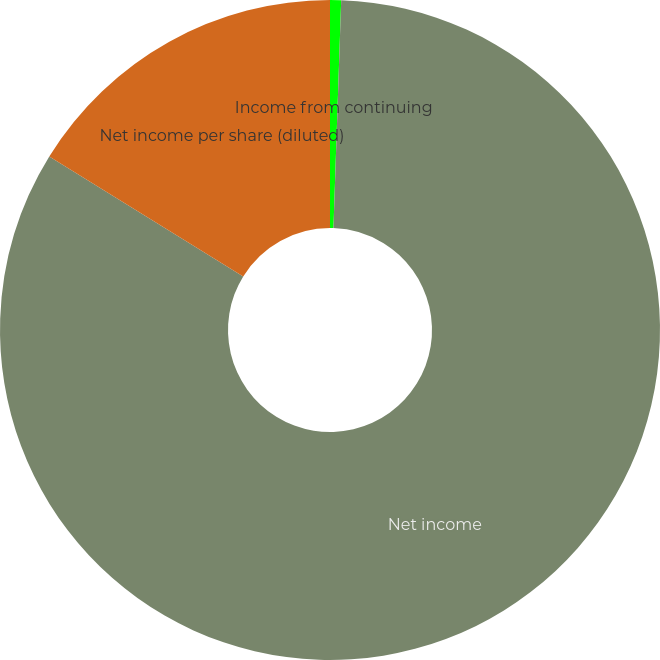Convert chart. <chart><loc_0><loc_0><loc_500><loc_500><pie_chart><fcel>Income from continuing<fcel>Net income<fcel>Net income per share (diluted)<nl><fcel>0.54%<fcel>83.27%<fcel>16.19%<nl></chart> 